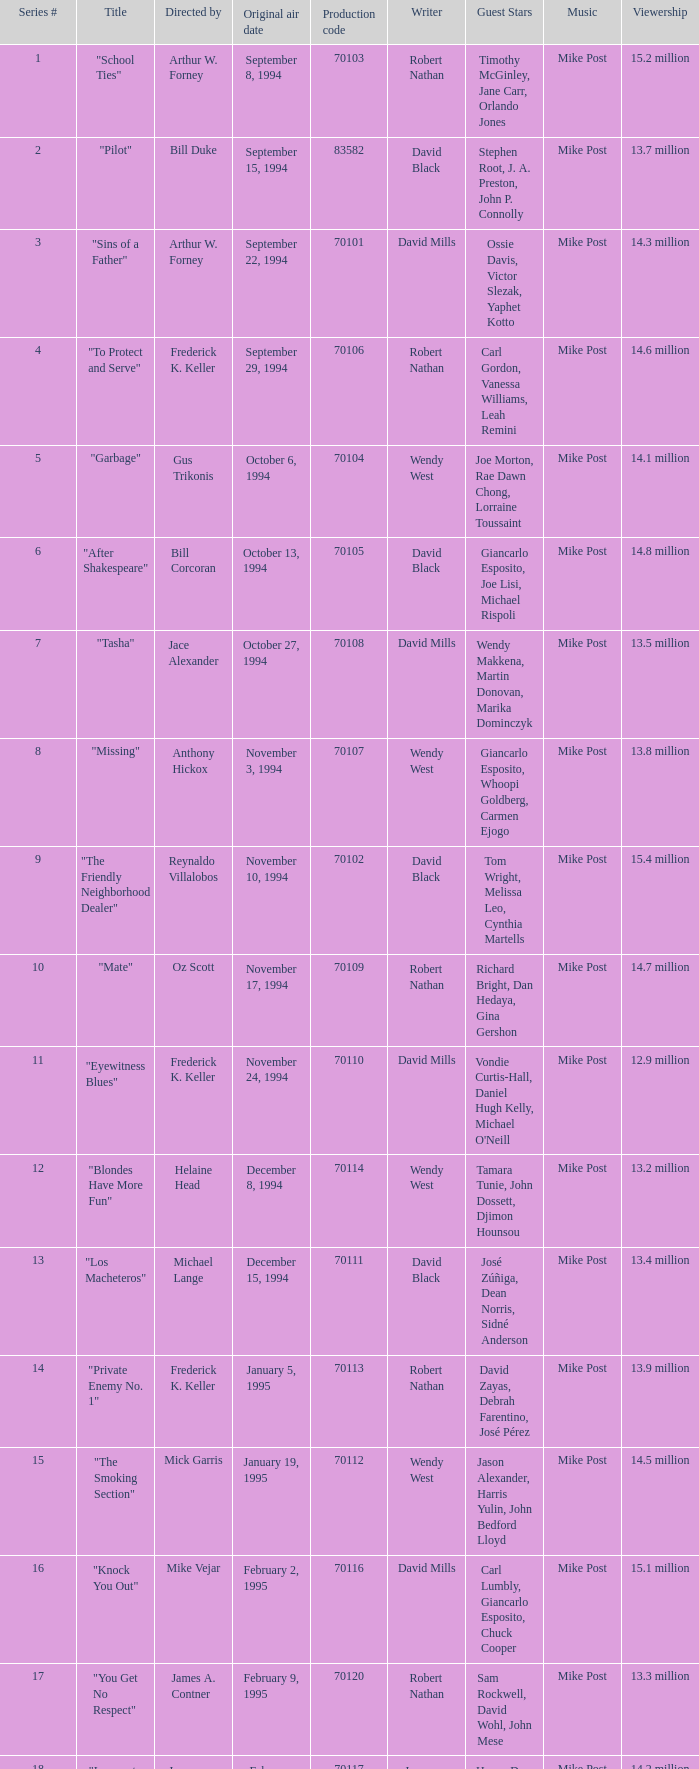For the "Downtown Girl" episode, what was the original air date? May 4, 1995. 